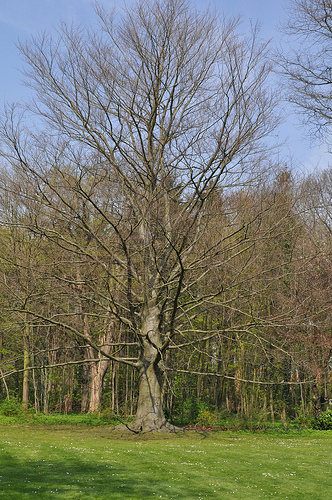<image>
Can you confirm if the plants is under the sky? Yes. The plants is positioned underneath the sky, with the sky above it in the vertical space. 